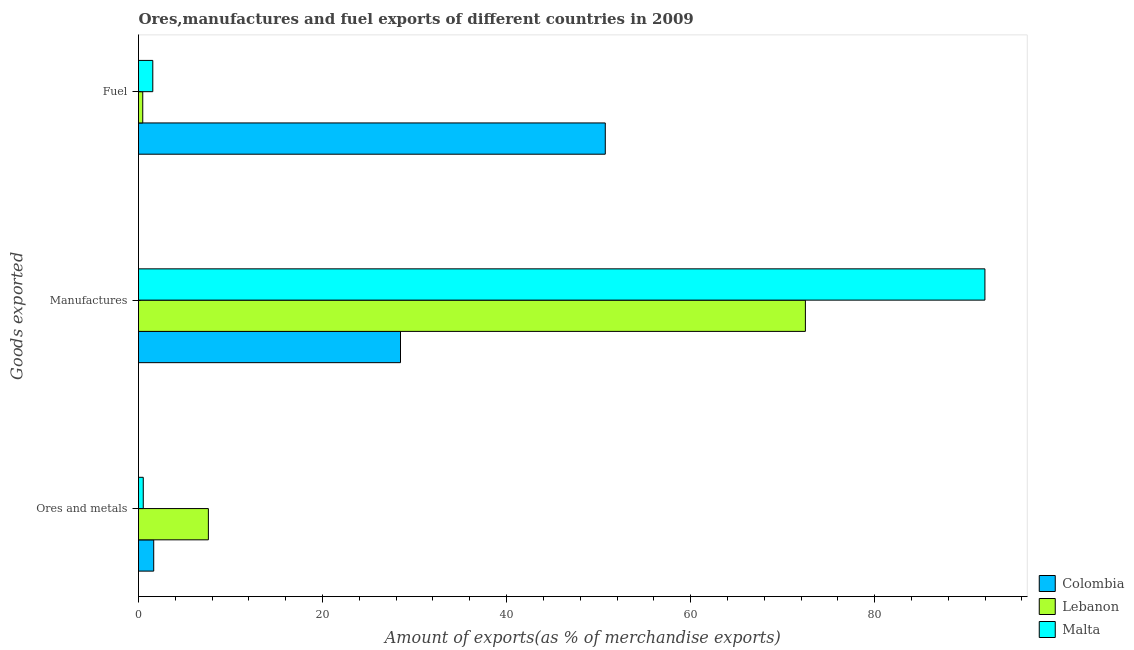How many bars are there on the 1st tick from the top?
Your response must be concise. 3. How many bars are there on the 2nd tick from the bottom?
Ensure brevity in your answer.  3. What is the label of the 1st group of bars from the top?
Your response must be concise. Fuel. What is the percentage of ores and metals exports in Lebanon?
Your answer should be very brief. 7.59. Across all countries, what is the maximum percentage of fuel exports?
Provide a succinct answer. 50.72. Across all countries, what is the minimum percentage of manufactures exports?
Keep it short and to the point. 28.47. In which country was the percentage of manufactures exports maximum?
Provide a succinct answer. Malta. In which country was the percentage of ores and metals exports minimum?
Make the answer very short. Malta. What is the total percentage of ores and metals exports in the graph?
Give a very brief answer. 9.76. What is the difference between the percentage of ores and metals exports in Colombia and that in Malta?
Ensure brevity in your answer.  1.14. What is the difference between the percentage of fuel exports in Colombia and the percentage of manufactures exports in Malta?
Your answer should be compact. -41.25. What is the average percentage of ores and metals exports per country?
Make the answer very short. 3.25. What is the difference between the percentage of ores and metals exports and percentage of manufactures exports in Colombia?
Your answer should be very brief. -26.82. In how many countries, is the percentage of manufactures exports greater than 52 %?
Your answer should be compact. 2. What is the ratio of the percentage of ores and metals exports in Colombia to that in Malta?
Offer a terse response. 3.2. Is the percentage of ores and metals exports in Colombia less than that in Lebanon?
Provide a short and direct response. Yes. Is the difference between the percentage of fuel exports in Malta and Colombia greater than the difference between the percentage of manufactures exports in Malta and Colombia?
Provide a short and direct response. No. What is the difference between the highest and the second highest percentage of ores and metals exports?
Make the answer very short. 5.94. What is the difference between the highest and the lowest percentage of manufactures exports?
Offer a terse response. 63.51. In how many countries, is the percentage of fuel exports greater than the average percentage of fuel exports taken over all countries?
Make the answer very short. 1. What does the 2nd bar from the top in Ores and metals represents?
Provide a succinct answer. Lebanon. What does the 2nd bar from the bottom in Ores and metals represents?
Provide a succinct answer. Lebanon. Are all the bars in the graph horizontal?
Your answer should be very brief. Yes. Does the graph contain any zero values?
Your answer should be very brief. No. Does the graph contain grids?
Offer a very short reply. No. What is the title of the graph?
Make the answer very short. Ores,manufactures and fuel exports of different countries in 2009. What is the label or title of the X-axis?
Your answer should be compact. Amount of exports(as % of merchandise exports). What is the label or title of the Y-axis?
Your answer should be very brief. Goods exported. What is the Amount of exports(as % of merchandise exports) of Colombia in Ores and metals?
Ensure brevity in your answer.  1.65. What is the Amount of exports(as % of merchandise exports) of Lebanon in Ores and metals?
Keep it short and to the point. 7.59. What is the Amount of exports(as % of merchandise exports) of Malta in Ores and metals?
Your answer should be very brief. 0.52. What is the Amount of exports(as % of merchandise exports) in Colombia in Manufactures?
Keep it short and to the point. 28.47. What is the Amount of exports(as % of merchandise exports) of Lebanon in Manufactures?
Ensure brevity in your answer.  72.47. What is the Amount of exports(as % of merchandise exports) of Malta in Manufactures?
Your response must be concise. 91.98. What is the Amount of exports(as % of merchandise exports) in Colombia in Fuel?
Make the answer very short. 50.72. What is the Amount of exports(as % of merchandise exports) in Lebanon in Fuel?
Your answer should be very brief. 0.46. What is the Amount of exports(as % of merchandise exports) in Malta in Fuel?
Provide a succinct answer. 1.55. Across all Goods exported, what is the maximum Amount of exports(as % of merchandise exports) of Colombia?
Make the answer very short. 50.72. Across all Goods exported, what is the maximum Amount of exports(as % of merchandise exports) of Lebanon?
Your answer should be compact. 72.47. Across all Goods exported, what is the maximum Amount of exports(as % of merchandise exports) of Malta?
Provide a succinct answer. 91.98. Across all Goods exported, what is the minimum Amount of exports(as % of merchandise exports) of Colombia?
Keep it short and to the point. 1.65. Across all Goods exported, what is the minimum Amount of exports(as % of merchandise exports) in Lebanon?
Keep it short and to the point. 0.46. Across all Goods exported, what is the minimum Amount of exports(as % of merchandise exports) of Malta?
Offer a very short reply. 0.52. What is the total Amount of exports(as % of merchandise exports) of Colombia in the graph?
Give a very brief answer. 80.84. What is the total Amount of exports(as % of merchandise exports) of Lebanon in the graph?
Offer a very short reply. 80.52. What is the total Amount of exports(as % of merchandise exports) in Malta in the graph?
Provide a succinct answer. 94.05. What is the difference between the Amount of exports(as % of merchandise exports) of Colombia in Ores and metals and that in Manufactures?
Provide a short and direct response. -26.82. What is the difference between the Amount of exports(as % of merchandise exports) in Lebanon in Ores and metals and that in Manufactures?
Ensure brevity in your answer.  -64.87. What is the difference between the Amount of exports(as % of merchandise exports) in Malta in Ores and metals and that in Manufactures?
Give a very brief answer. -91.46. What is the difference between the Amount of exports(as % of merchandise exports) of Colombia in Ores and metals and that in Fuel?
Make the answer very short. -49.07. What is the difference between the Amount of exports(as % of merchandise exports) in Lebanon in Ores and metals and that in Fuel?
Your answer should be very brief. 7.13. What is the difference between the Amount of exports(as % of merchandise exports) in Malta in Ores and metals and that in Fuel?
Give a very brief answer. -1.04. What is the difference between the Amount of exports(as % of merchandise exports) in Colombia in Manufactures and that in Fuel?
Ensure brevity in your answer.  -22.25. What is the difference between the Amount of exports(as % of merchandise exports) of Lebanon in Manufactures and that in Fuel?
Your response must be concise. 72.01. What is the difference between the Amount of exports(as % of merchandise exports) of Malta in Manufactures and that in Fuel?
Your answer should be very brief. 90.42. What is the difference between the Amount of exports(as % of merchandise exports) of Colombia in Ores and metals and the Amount of exports(as % of merchandise exports) of Lebanon in Manufactures?
Offer a very short reply. -70.81. What is the difference between the Amount of exports(as % of merchandise exports) of Colombia in Ores and metals and the Amount of exports(as % of merchandise exports) of Malta in Manufactures?
Offer a terse response. -90.32. What is the difference between the Amount of exports(as % of merchandise exports) of Lebanon in Ores and metals and the Amount of exports(as % of merchandise exports) of Malta in Manufactures?
Offer a very short reply. -84.38. What is the difference between the Amount of exports(as % of merchandise exports) of Colombia in Ores and metals and the Amount of exports(as % of merchandise exports) of Lebanon in Fuel?
Keep it short and to the point. 1.19. What is the difference between the Amount of exports(as % of merchandise exports) in Colombia in Ores and metals and the Amount of exports(as % of merchandise exports) in Malta in Fuel?
Provide a short and direct response. 0.1. What is the difference between the Amount of exports(as % of merchandise exports) of Lebanon in Ores and metals and the Amount of exports(as % of merchandise exports) of Malta in Fuel?
Your response must be concise. 6.04. What is the difference between the Amount of exports(as % of merchandise exports) of Colombia in Manufactures and the Amount of exports(as % of merchandise exports) of Lebanon in Fuel?
Keep it short and to the point. 28.01. What is the difference between the Amount of exports(as % of merchandise exports) of Colombia in Manufactures and the Amount of exports(as % of merchandise exports) of Malta in Fuel?
Your answer should be compact. 26.92. What is the difference between the Amount of exports(as % of merchandise exports) of Lebanon in Manufactures and the Amount of exports(as % of merchandise exports) of Malta in Fuel?
Your response must be concise. 70.91. What is the average Amount of exports(as % of merchandise exports) in Colombia per Goods exported?
Offer a terse response. 26.95. What is the average Amount of exports(as % of merchandise exports) in Lebanon per Goods exported?
Your answer should be very brief. 26.84. What is the average Amount of exports(as % of merchandise exports) of Malta per Goods exported?
Your response must be concise. 31.35. What is the difference between the Amount of exports(as % of merchandise exports) in Colombia and Amount of exports(as % of merchandise exports) in Lebanon in Ores and metals?
Ensure brevity in your answer.  -5.94. What is the difference between the Amount of exports(as % of merchandise exports) of Colombia and Amount of exports(as % of merchandise exports) of Malta in Ores and metals?
Make the answer very short. 1.14. What is the difference between the Amount of exports(as % of merchandise exports) of Lebanon and Amount of exports(as % of merchandise exports) of Malta in Ores and metals?
Your answer should be very brief. 7.08. What is the difference between the Amount of exports(as % of merchandise exports) of Colombia and Amount of exports(as % of merchandise exports) of Lebanon in Manufactures?
Your answer should be very brief. -44. What is the difference between the Amount of exports(as % of merchandise exports) in Colombia and Amount of exports(as % of merchandise exports) in Malta in Manufactures?
Ensure brevity in your answer.  -63.51. What is the difference between the Amount of exports(as % of merchandise exports) of Lebanon and Amount of exports(as % of merchandise exports) of Malta in Manufactures?
Make the answer very short. -19.51. What is the difference between the Amount of exports(as % of merchandise exports) in Colombia and Amount of exports(as % of merchandise exports) in Lebanon in Fuel?
Offer a terse response. 50.26. What is the difference between the Amount of exports(as % of merchandise exports) of Colombia and Amount of exports(as % of merchandise exports) of Malta in Fuel?
Your response must be concise. 49.17. What is the difference between the Amount of exports(as % of merchandise exports) in Lebanon and Amount of exports(as % of merchandise exports) in Malta in Fuel?
Ensure brevity in your answer.  -1.09. What is the ratio of the Amount of exports(as % of merchandise exports) in Colombia in Ores and metals to that in Manufactures?
Offer a terse response. 0.06. What is the ratio of the Amount of exports(as % of merchandise exports) of Lebanon in Ores and metals to that in Manufactures?
Offer a very short reply. 0.1. What is the ratio of the Amount of exports(as % of merchandise exports) in Malta in Ores and metals to that in Manufactures?
Your answer should be compact. 0.01. What is the ratio of the Amount of exports(as % of merchandise exports) of Colombia in Ores and metals to that in Fuel?
Keep it short and to the point. 0.03. What is the ratio of the Amount of exports(as % of merchandise exports) of Lebanon in Ores and metals to that in Fuel?
Your answer should be very brief. 16.45. What is the ratio of the Amount of exports(as % of merchandise exports) in Malta in Ores and metals to that in Fuel?
Your response must be concise. 0.33. What is the ratio of the Amount of exports(as % of merchandise exports) in Colombia in Manufactures to that in Fuel?
Ensure brevity in your answer.  0.56. What is the ratio of the Amount of exports(as % of merchandise exports) of Lebanon in Manufactures to that in Fuel?
Provide a short and direct response. 157.02. What is the ratio of the Amount of exports(as % of merchandise exports) of Malta in Manufactures to that in Fuel?
Keep it short and to the point. 59.21. What is the difference between the highest and the second highest Amount of exports(as % of merchandise exports) in Colombia?
Make the answer very short. 22.25. What is the difference between the highest and the second highest Amount of exports(as % of merchandise exports) of Lebanon?
Your answer should be very brief. 64.87. What is the difference between the highest and the second highest Amount of exports(as % of merchandise exports) in Malta?
Make the answer very short. 90.42. What is the difference between the highest and the lowest Amount of exports(as % of merchandise exports) in Colombia?
Ensure brevity in your answer.  49.07. What is the difference between the highest and the lowest Amount of exports(as % of merchandise exports) in Lebanon?
Ensure brevity in your answer.  72.01. What is the difference between the highest and the lowest Amount of exports(as % of merchandise exports) of Malta?
Provide a short and direct response. 91.46. 